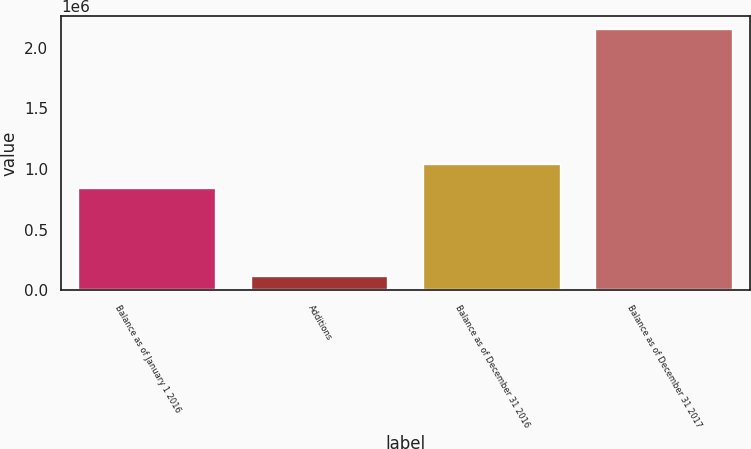<chart> <loc_0><loc_0><loc_500><loc_500><bar_chart><fcel>Balance as of January 1 2016<fcel>Additions<fcel>Balance as of December 31 2016<fcel>Balance as of December 31 2017<nl><fcel>840582<fcel>119295<fcel>1.04405e+06<fcel>2.15399e+06<nl></chart> 